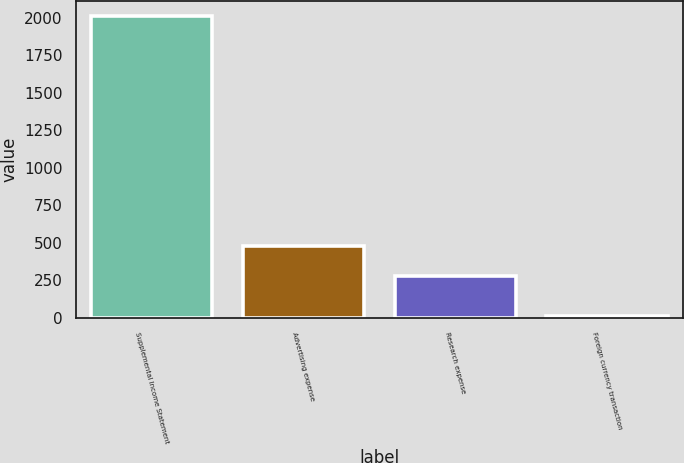Convert chart to OTSL. <chart><loc_0><loc_0><loc_500><loc_500><bar_chart><fcel>Supplemental Income Statement<fcel>Advertising expense<fcel>Research expense<fcel>Foreign currency transaction<nl><fcel>2007<fcel>476.25<fcel>276.8<fcel>12.5<nl></chart> 